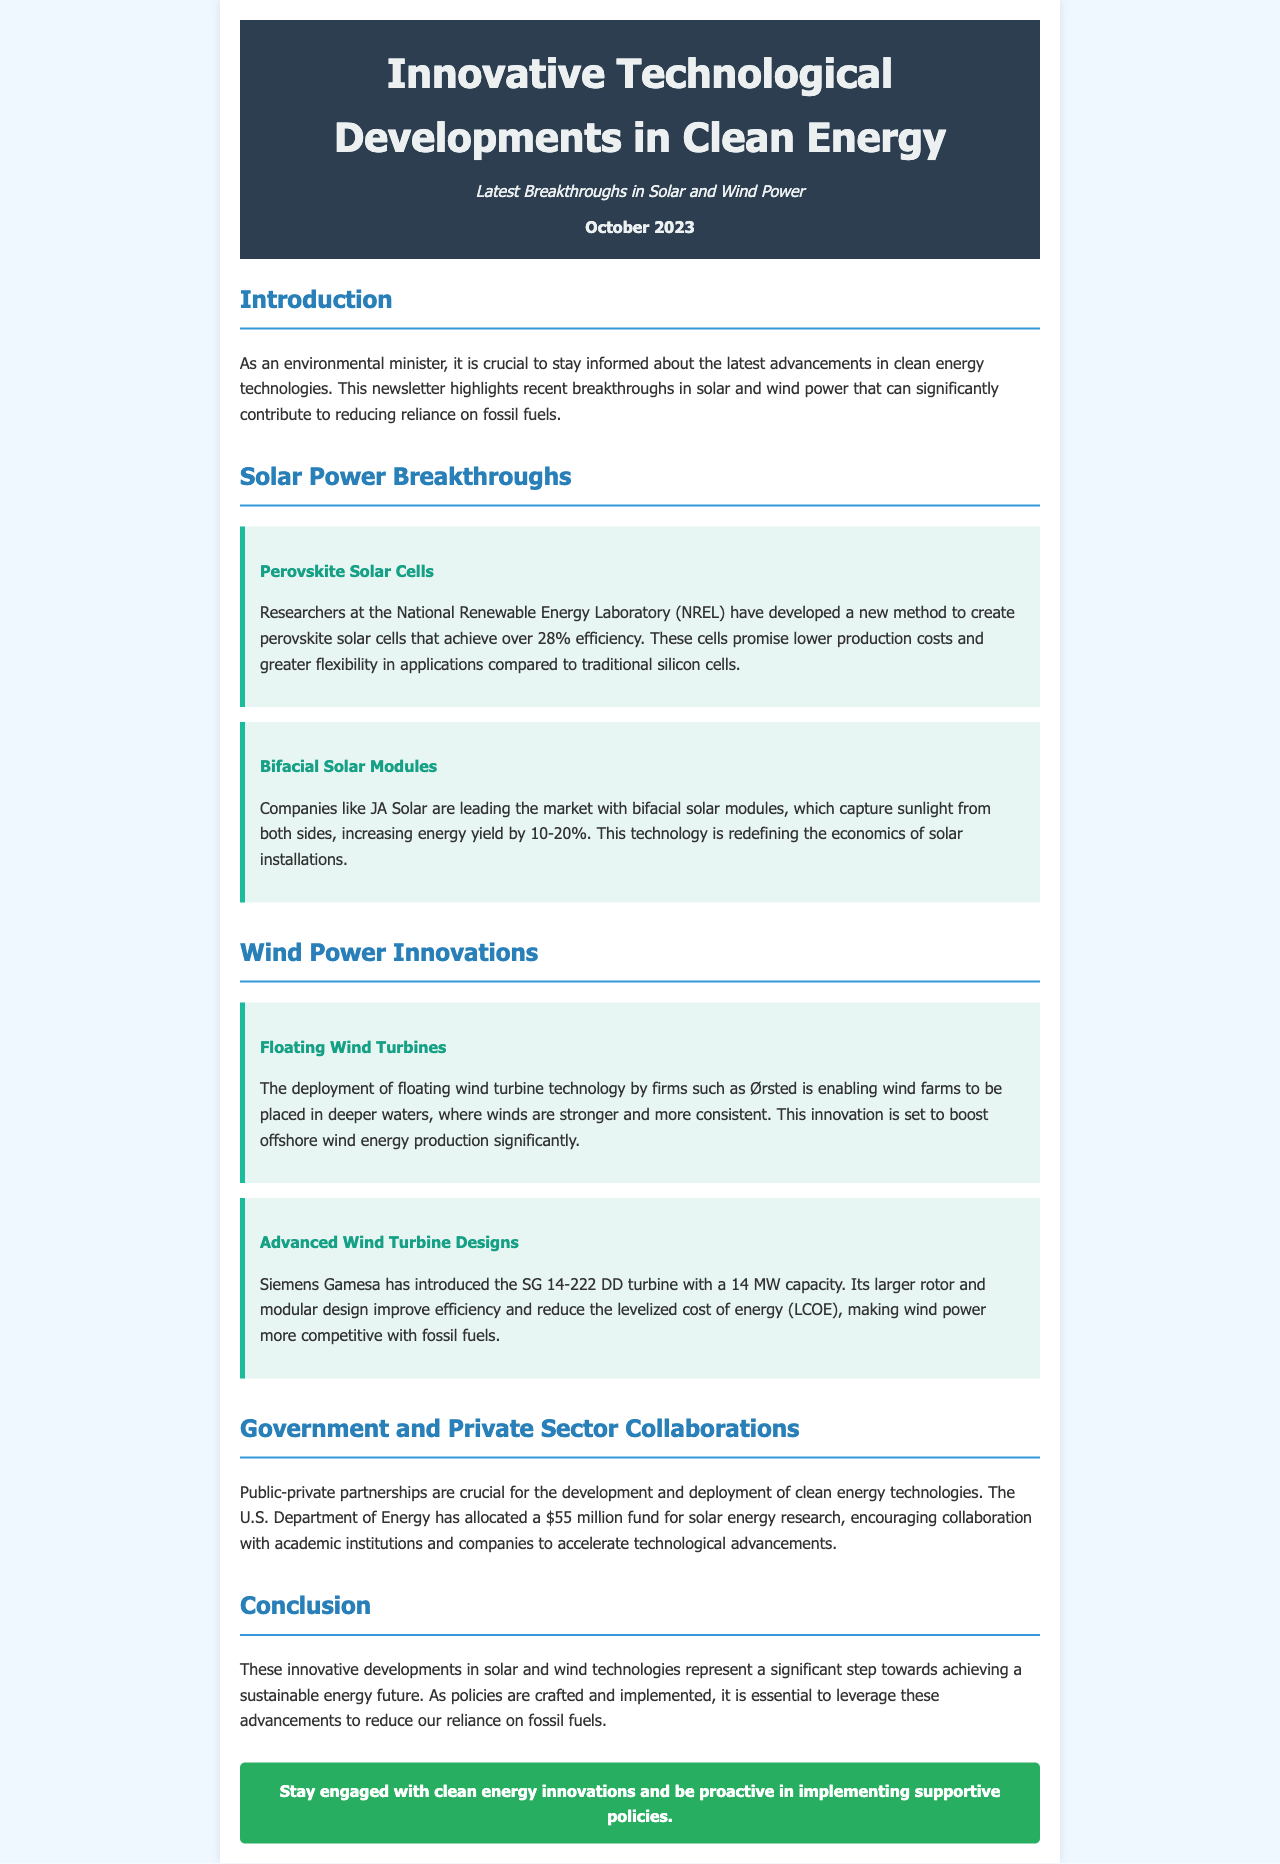What is the efficiency of perovskite solar cells? The document states that researchers have developed perovskite solar cells that achieve over 28% efficiency.
Answer: 28% Which company produces bifacial solar modules? The document mentions that companies like JA Solar are leading the market with bifacial solar modules.
Answer: JA Solar What is the capacity of the SG 14-222 DD turbine? According to the document, Siemens Gamesa has introduced the SG 14-222 DD turbine with a capacity of 14 MW.
Answer: 14 MW What funding amount has the U.S. Department of Energy allocated for solar energy research? The document notes that the U.S. Department of Energy has allocated a $55 million fund for solar energy research.
Answer: $55 million What are the benefits of floating wind turbine technology? The document explains that floating wind turbine technology enables wind farms to be placed in deeper waters, boosting offshore wind energy production.
Answer: Deeper waters Why are public-private partnerships important for clean energy development? The document states that public-private partnerships are crucial for the development and deployment of clean energy technologies.
Answer: Development and deployment What is the main focus of this newsletter? The document indicates that the main focus of the newsletter is on the latest breakthroughs in solar and wind power that can significantly contribute to reducing reliance on fossil fuels.
Answer: Reducing reliance on fossil fuels When was the newsletter published? The newsletter indicates that it was published in October 2023.
Answer: October 2023 